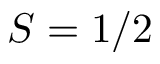<formula> <loc_0><loc_0><loc_500><loc_500>S = 1 / 2</formula> 